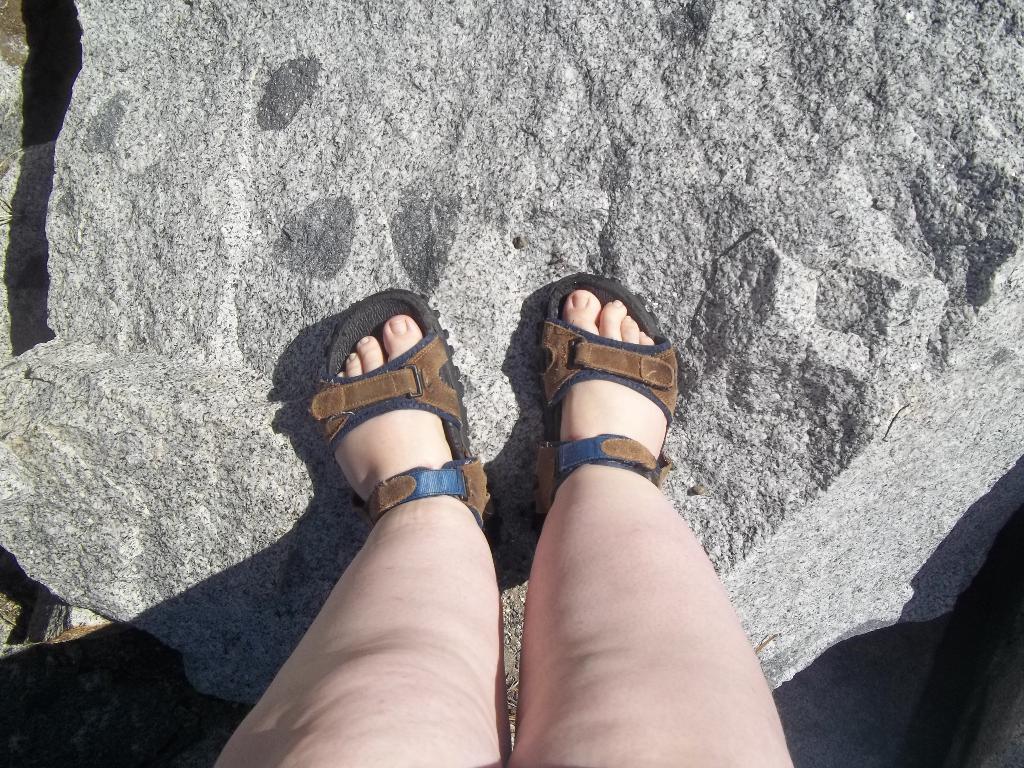How would you summarize this image in a sentence or two? In this picture I can observe two human legs. There are two sandals. I can observe a rock in this picture. 